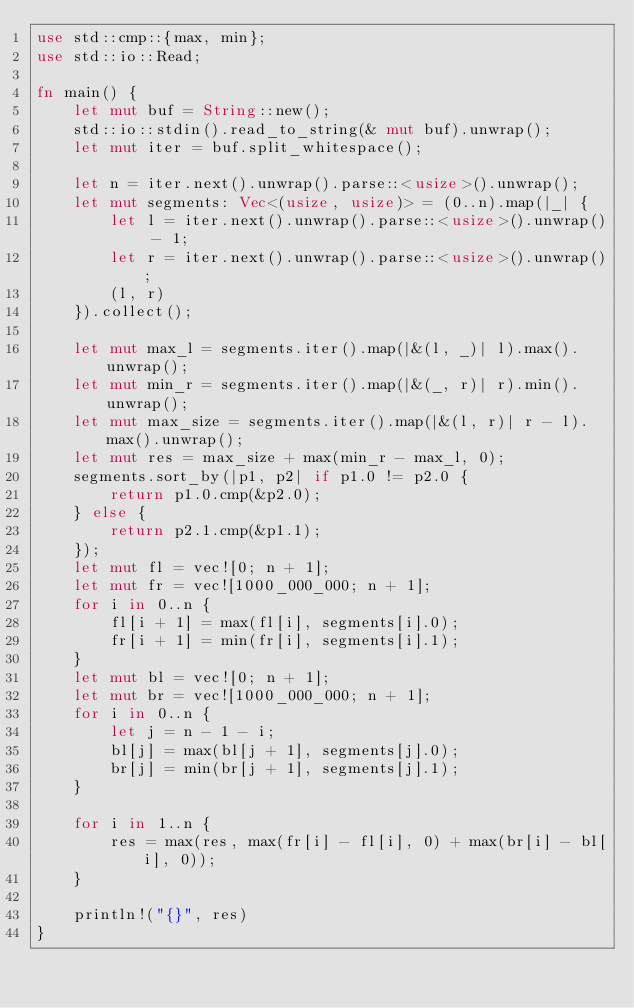Convert code to text. <code><loc_0><loc_0><loc_500><loc_500><_Rust_>use std::cmp::{max, min};
use std::io::Read;

fn main() {
    let mut buf = String::new();
    std::io::stdin().read_to_string(& mut buf).unwrap();
    let mut iter = buf.split_whitespace();

    let n = iter.next().unwrap().parse::<usize>().unwrap();
    let mut segments: Vec<(usize, usize)> = (0..n).map(|_| {
        let l = iter.next().unwrap().parse::<usize>().unwrap() - 1;
        let r = iter.next().unwrap().parse::<usize>().unwrap();
        (l, r)
    }).collect();

    let mut max_l = segments.iter().map(|&(l, _)| l).max().unwrap();
    let mut min_r = segments.iter().map(|&(_, r)| r).min().unwrap();
    let mut max_size = segments.iter().map(|&(l, r)| r - l).max().unwrap();
    let mut res = max_size + max(min_r - max_l, 0);
    segments.sort_by(|p1, p2| if p1.0 != p2.0 {
        return p1.0.cmp(&p2.0);
    } else {
        return p2.1.cmp(&p1.1);
    });
    let mut fl = vec![0; n + 1];
    let mut fr = vec![1000_000_000; n + 1];
    for i in 0..n {
        fl[i + 1] = max(fl[i], segments[i].0);
        fr[i + 1] = min(fr[i], segments[i].1);
    }
    let mut bl = vec![0; n + 1];
    let mut br = vec![1000_000_000; n + 1];
    for i in 0..n {
        let j = n - 1 - i;
        bl[j] = max(bl[j + 1], segments[j].0);
        br[j] = min(br[j + 1], segments[j].1);
    }

    for i in 1..n {
        res = max(res, max(fr[i] - fl[i], 0) + max(br[i] - bl[i], 0));
    }

    println!("{}", res)
}</code> 